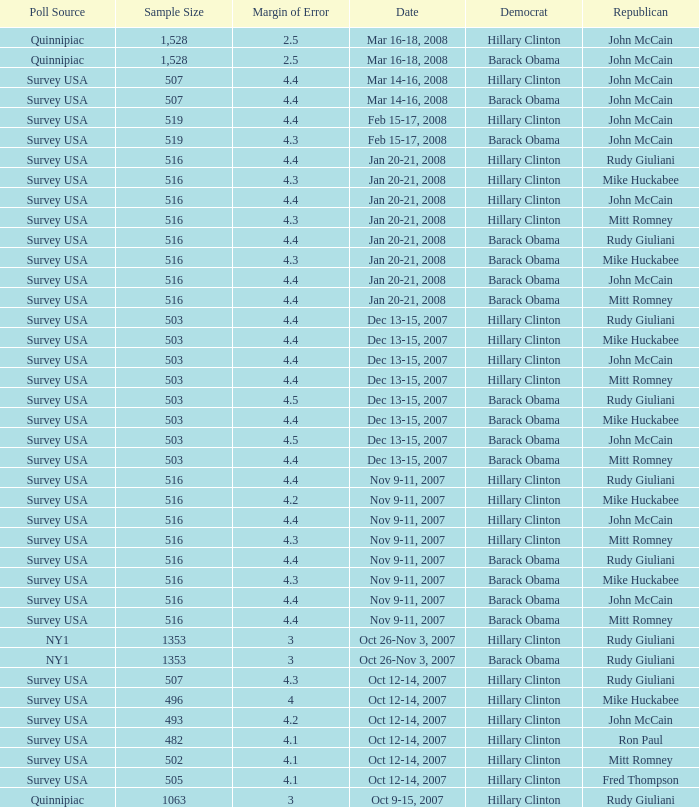When was the poll featuring a sample size of 496 and choosing republican mike huckabee held? Oct 12-14, 2007. 